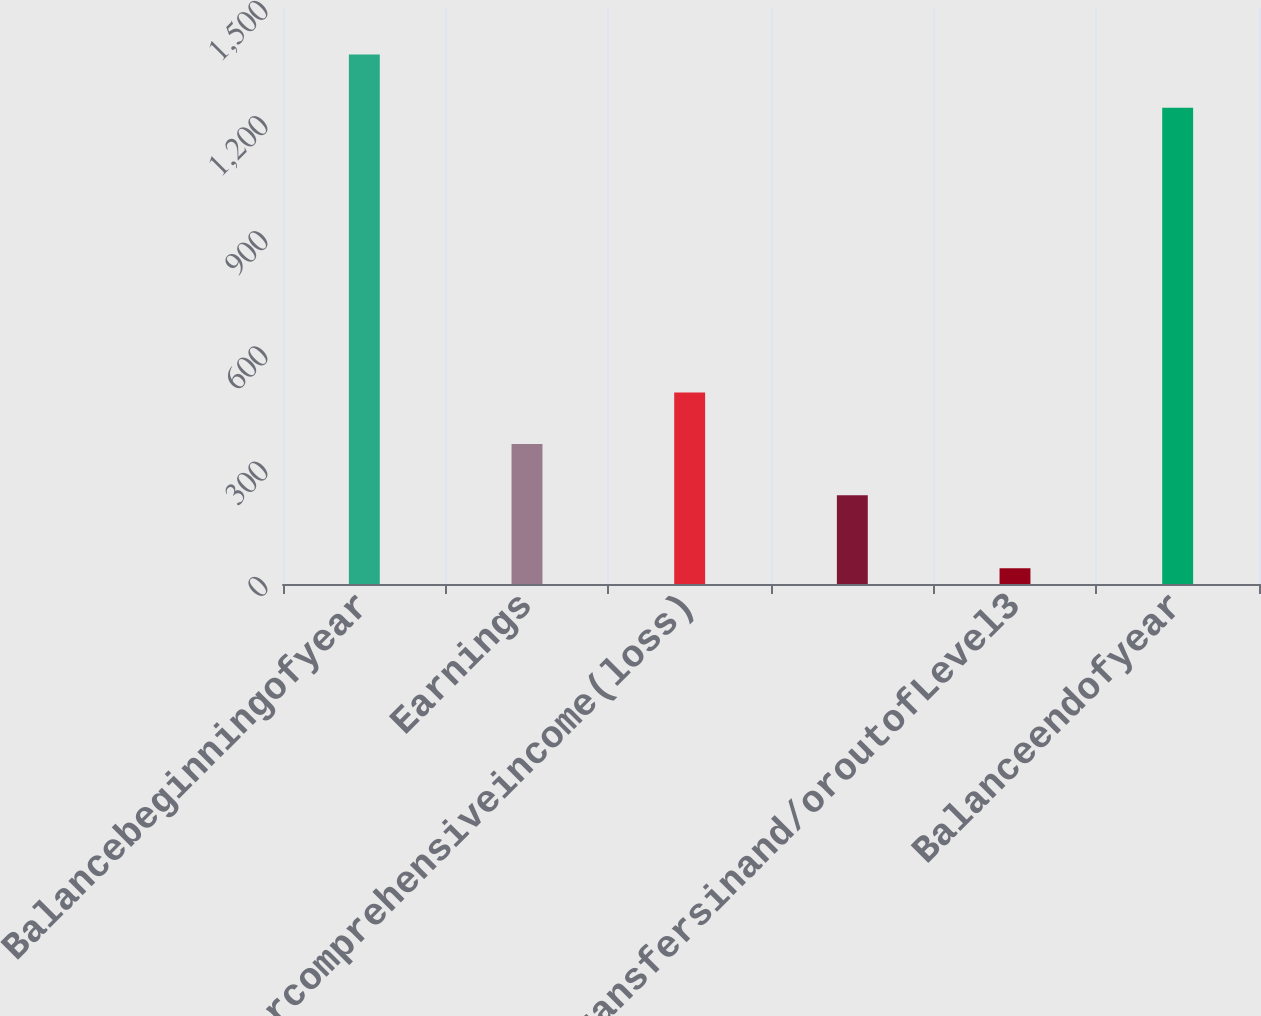Convert chart. <chart><loc_0><loc_0><loc_500><loc_500><bar_chart><fcel>Balancebeginningofyear<fcel>Earnings<fcel>Othercomprehensiveincome(loss)<fcel>Unnamed: 3<fcel>Transfersinand/oroutofLevel3<fcel>Balanceendofyear<nl><fcel>1379<fcel>364.8<fcel>498.6<fcel>231<fcel>41<fcel>1240<nl></chart> 